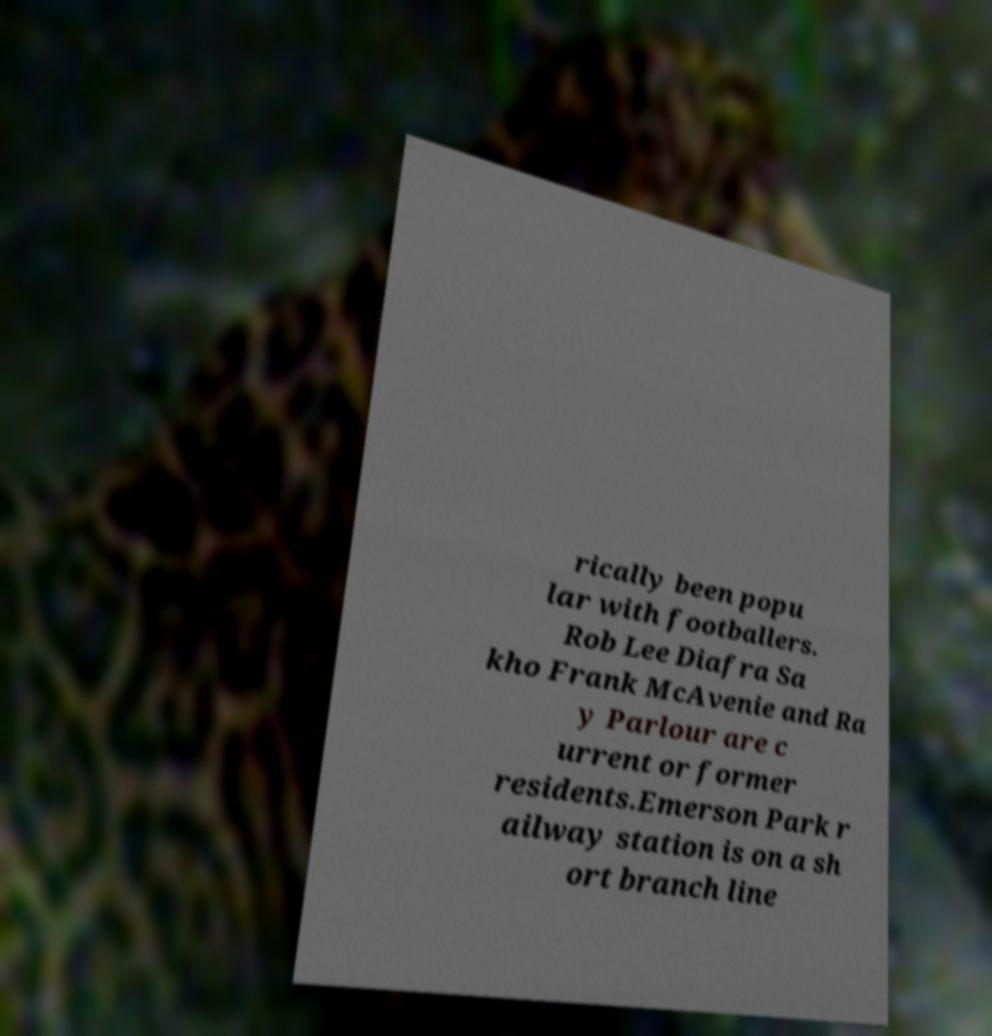For documentation purposes, I need the text within this image transcribed. Could you provide that? rically been popu lar with footballers. Rob Lee Diafra Sa kho Frank McAvenie and Ra y Parlour are c urrent or former residents.Emerson Park r ailway station is on a sh ort branch line 